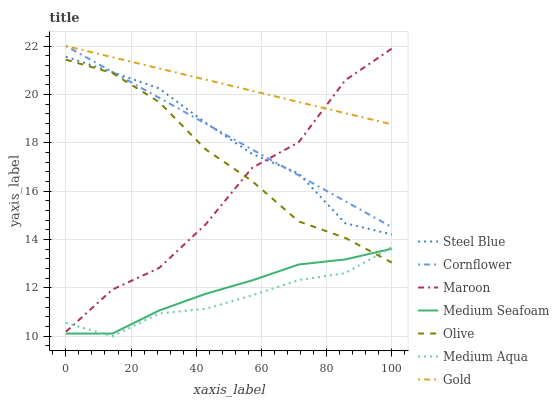Does Steel Blue have the minimum area under the curve?
Answer yes or no. No. Does Steel Blue have the maximum area under the curve?
Answer yes or no. No. Is Steel Blue the smoothest?
Answer yes or no. No. Is Steel Blue the roughest?
Answer yes or no. No. Does Steel Blue have the lowest value?
Answer yes or no. No. Does Steel Blue have the highest value?
Answer yes or no. No. Is Olive less than Gold?
Answer yes or no. Yes. Is Gold greater than Medium Seafoam?
Answer yes or no. Yes. Does Olive intersect Gold?
Answer yes or no. No. 